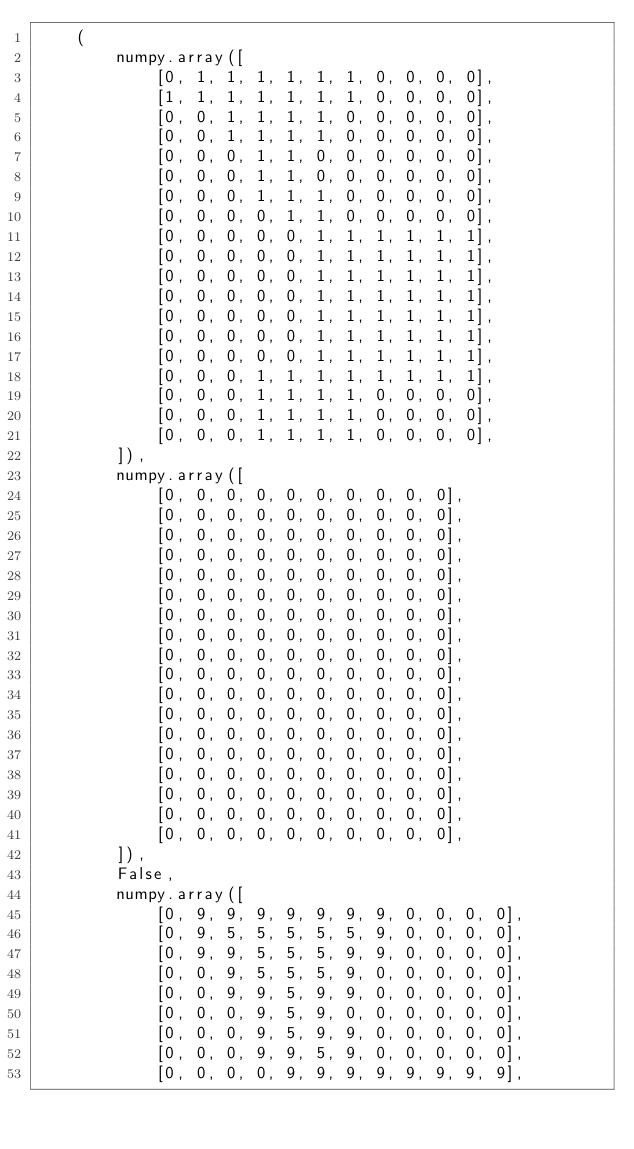Convert code to text. <code><loc_0><loc_0><loc_500><loc_500><_Python_>    (
        numpy.array([
            [0, 1, 1, 1, 1, 1, 1, 0, 0, 0, 0],
            [1, 1, 1, 1, 1, 1, 1, 0, 0, 0, 0],
            [0, 0, 1, 1, 1, 1, 0, 0, 0, 0, 0],
            [0, 0, 1, 1, 1, 1, 0, 0, 0, 0, 0],
            [0, 0, 0, 1, 1, 0, 0, 0, 0, 0, 0],
            [0, 0, 0, 1, 1, 0, 0, 0, 0, 0, 0],
            [0, 0, 0, 1, 1, 1, 0, 0, 0, 0, 0],
            [0, 0, 0, 0, 1, 1, 0, 0, 0, 0, 0],
            [0, 0, 0, 0, 0, 1, 1, 1, 1, 1, 1],
            [0, 0, 0, 0, 0, 1, 1, 1, 1, 1, 1],
            [0, 0, 0, 0, 0, 1, 1, 1, 1, 1, 1],
            [0, 0, 0, 0, 0, 1, 1, 1, 1, 1, 1],
            [0, 0, 0, 0, 0, 1, 1, 1, 1, 1, 1],
            [0, 0, 0, 0, 0, 1, 1, 1, 1, 1, 1],
            [0, 0, 0, 0, 0, 1, 1, 1, 1, 1, 1],
            [0, 0, 0, 1, 1, 1, 1, 1, 1, 1, 1],
            [0, 0, 0, 1, 1, 1, 1, 0, 0, 0, 0],
            [0, 0, 0, 1, 1, 1, 1, 0, 0, 0, 0],
            [0, 0, 0, 1, 1, 1, 1, 0, 0, 0, 0],
        ]),
        numpy.array([
            [0, 0, 0, 0, 0, 0, 0, 0, 0, 0],
            [0, 0, 0, 0, 0, 0, 0, 0, 0, 0],
            [0, 0, 0, 0, 0, 0, 0, 0, 0, 0],
            [0, 0, 0, 0, 0, 0, 0, 0, 0, 0],
            [0, 0, 0, 0, 0, 0, 0, 0, 0, 0],
            [0, 0, 0, 0, 0, 0, 0, 0, 0, 0],
            [0, 0, 0, 0, 0, 0, 0, 0, 0, 0],
            [0, 0, 0, 0, 0, 0, 0, 0, 0, 0],
            [0, 0, 0, 0, 0, 0, 0, 0, 0, 0],
            [0, 0, 0, 0, 0, 0, 0, 0, 0, 0],
            [0, 0, 0, 0, 0, 0, 0, 0, 0, 0],
            [0, 0, 0, 0, 0, 0, 0, 0, 0, 0],
            [0, 0, 0, 0, 0, 0, 0, 0, 0, 0],
            [0, 0, 0, 0, 0, 0, 0, 0, 0, 0],
            [0, 0, 0, 0, 0, 0, 0, 0, 0, 0],
            [0, 0, 0, 0, 0, 0, 0, 0, 0, 0],
            [0, 0, 0, 0, 0, 0, 0, 0, 0, 0],
            [0, 0, 0, 0, 0, 0, 0, 0, 0, 0],
        ]),
        False,
        numpy.array([
            [0, 9, 9, 9, 9, 9, 9, 9, 0, 0, 0, 0],
            [0, 9, 5, 5, 5, 5, 5, 9, 0, 0, 0, 0],
            [0, 9, 9, 5, 5, 5, 9, 9, 0, 0, 0, 0],
            [0, 0, 9, 5, 5, 5, 9, 0, 0, 0, 0, 0],
            [0, 0, 9, 9, 5, 9, 9, 0, 0, 0, 0, 0],
            [0, 0, 0, 9, 5, 9, 0, 0, 0, 0, 0, 0],
            [0, 0, 0, 9, 5, 9, 9, 0, 0, 0, 0, 0],
            [0, 0, 0, 9, 9, 5, 9, 0, 0, 0, 0, 0],
            [0, 0, 0, 0, 9, 9, 9, 9, 9, 9, 9, 9],</code> 